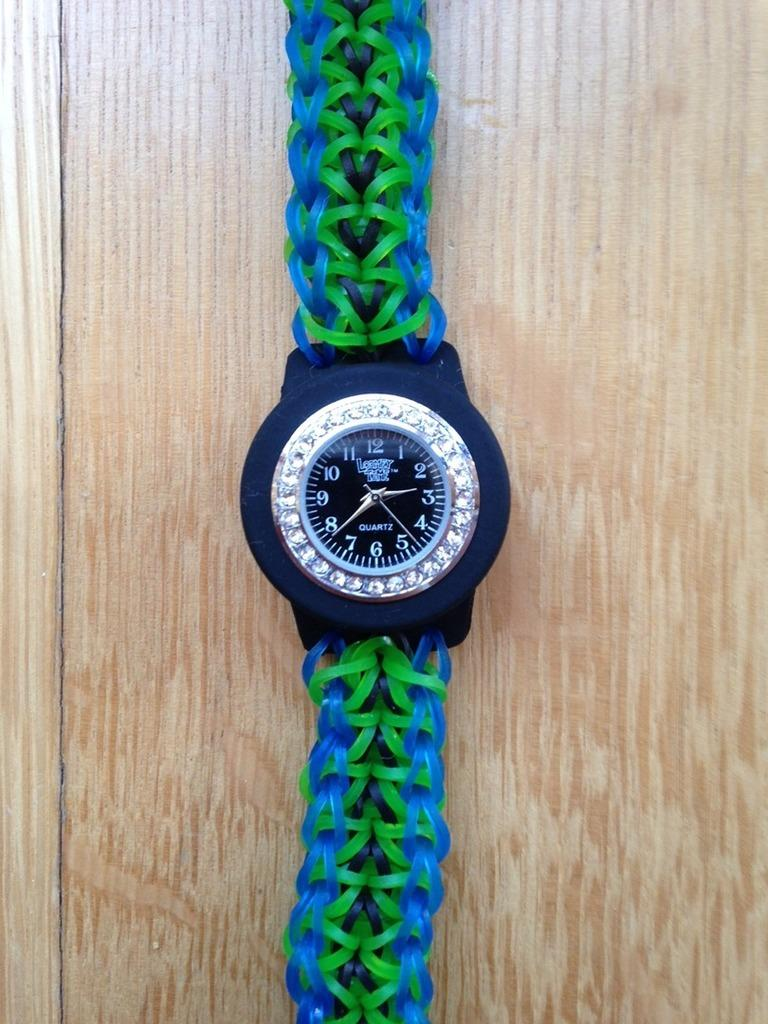<image>
Summarize the visual content of the image. A Quartz watch has a green and blue band. 